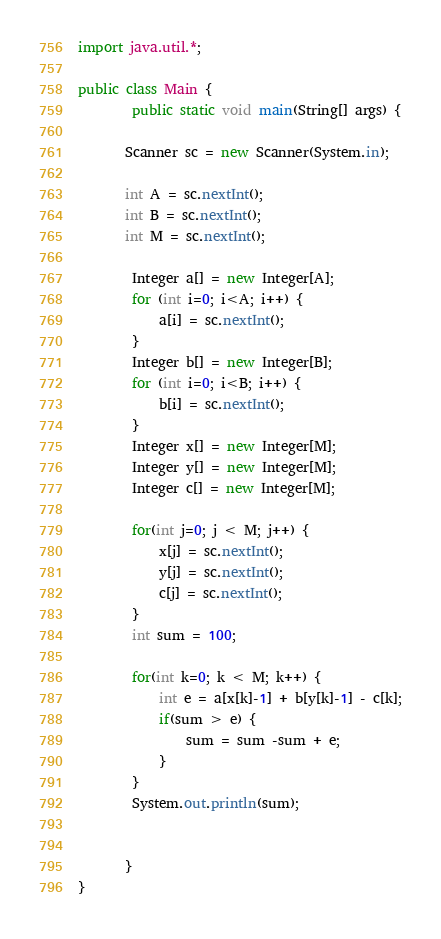<code> <loc_0><loc_0><loc_500><loc_500><_Java_>import java.util.*;

public class Main {
		public static void main(String[] args) {
		
	   Scanner sc = new Scanner(System.in);
	   
	   int A = sc.nextInt();
	   int B = sc.nextInt();
	   int M = sc.nextInt();
	   
		Integer a[] = new Integer[A];
		for (int i=0; i<A; i++) {
			a[i] = sc.nextInt();
		}
		Integer b[] = new Integer[B];
		for (int i=0; i<B; i++) {
			b[i] = sc.nextInt();
		}
		Integer x[] = new Integer[M];
		Integer y[] = new Integer[M];
		Integer c[] = new Integer[M];
		
		for(int j=0; j < M; j++) {
			x[j] = sc.nextInt();
			y[j] = sc.nextInt();
			c[j] = sc.nextInt();
		}
		int sum = 100;
		
		for(int k=0; k < M; k++) {
			int e = a[x[k]-1] + b[y[k]-1] - c[k];
			if(sum > e) {
				sum = sum -sum + e;
			}
		}
		System.out.println(sum);
	   
	   
	   }
}

</code> 